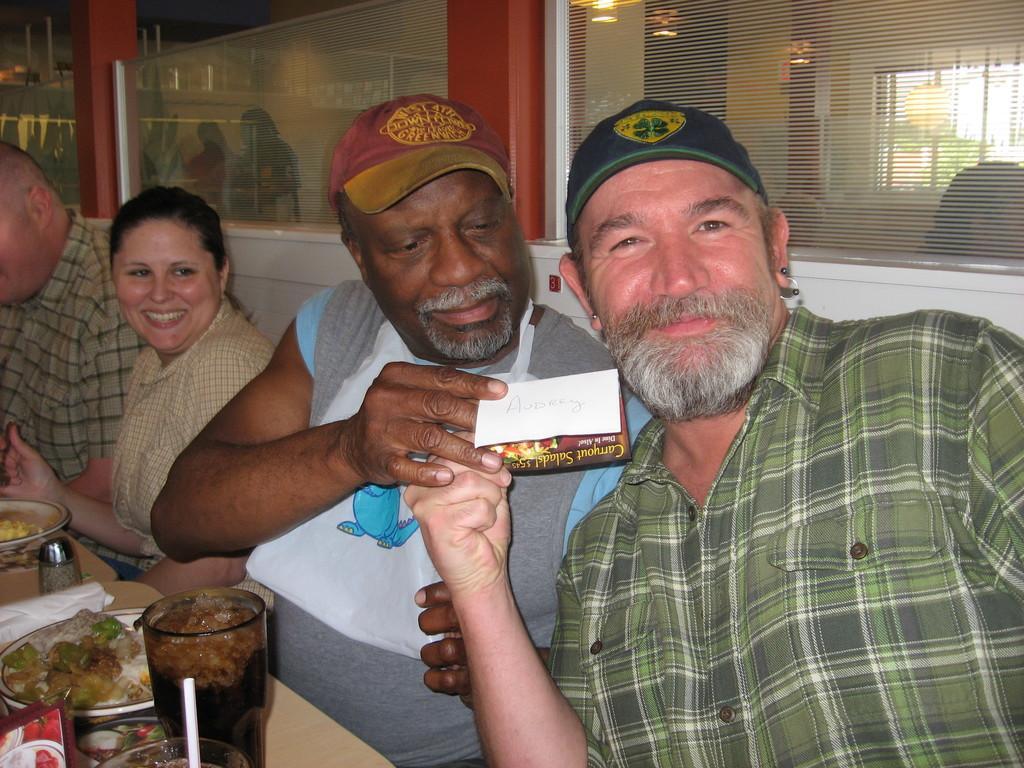How would you summarize this image in a sentence or two? In this image we can see a few people sitting, among them two people are holding an object, in front of them there is a table, on the table, we can see some plates with food, glass and other objects, in the background it looks like pillars and glass windows. 